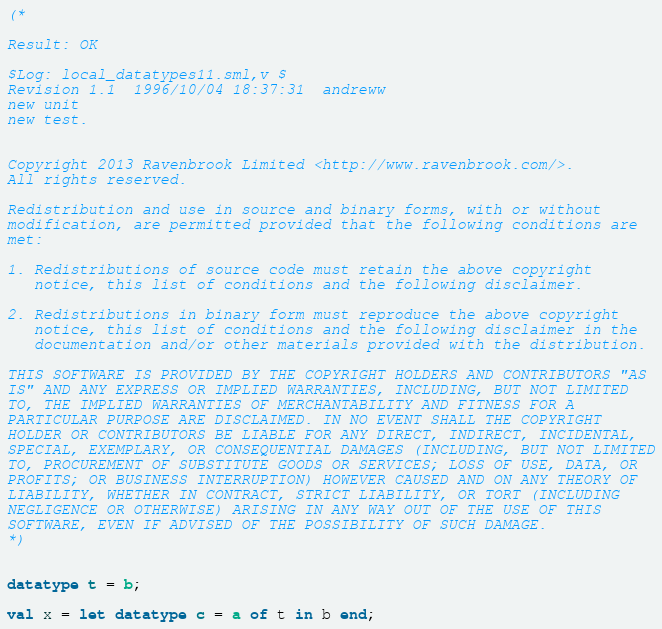Convert code to text. <code><loc_0><loc_0><loc_500><loc_500><_SML_>(*

Result: OK

$Log: local_datatypes11.sml,v $
Revision 1.1  1996/10/04 18:37:31  andreww
new unit
new test.


Copyright 2013 Ravenbrook Limited <http://www.ravenbrook.com/>.
All rights reserved.

Redistribution and use in source and binary forms, with or without
modification, are permitted provided that the following conditions are
met:

1. Redistributions of source code must retain the above copyright
   notice, this list of conditions and the following disclaimer.

2. Redistributions in binary form must reproduce the above copyright
   notice, this list of conditions and the following disclaimer in the
   documentation and/or other materials provided with the distribution.

THIS SOFTWARE IS PROVIDED BY THE COPYRIGHT HOLDERS AND CONTRIBUTORS "AS
IS" AND ANY EXPRESS OR IMPLIED WARRANTIES, INCLUDING, BUT NOT LIMITED
TO, THE IMPLIED WARRANTIES OF MERCHANTABILITY AND FITNESS FOR A
PARTICULAR PURPOSE ARE DISCLAIMED. IN NO EVENT SHALL THE COPYRIGHT
HOLDER OR CONTRIBUTORS BE LIABLE FOR ANY DIRECT, INDIRECT, INCIDENTAL,
SPECIAL, EXEMPLARY, OR CONSEQUENTIAL DAMAGES (INCLUDING, BUT NOT LIMITED
TO, PROCUREMENT OF SUBSTITUTE GOODS OR SERVICES; LOSS OF USE, DATA, OR
PROFITS; OR BUSINESS INTERRUPTION) HOWEVER CAUSED AND ON ANY THEORY OF
LIABILITY, WHETHER IN CONTRACT, STRICT LIABILITY, OR TORT (INCLUDING
NEGLIGENCE OR OTHERWISE) ARISING IN ANY WAY OUT OF THE USE OF THIS
SOFTWARE, EVEN IF ADVISED OF THE POSSIBILITY OF SUCH DAMAGE.
*)


datatype t = b;

val x = let datatype c = a of t in b end;




</code> 